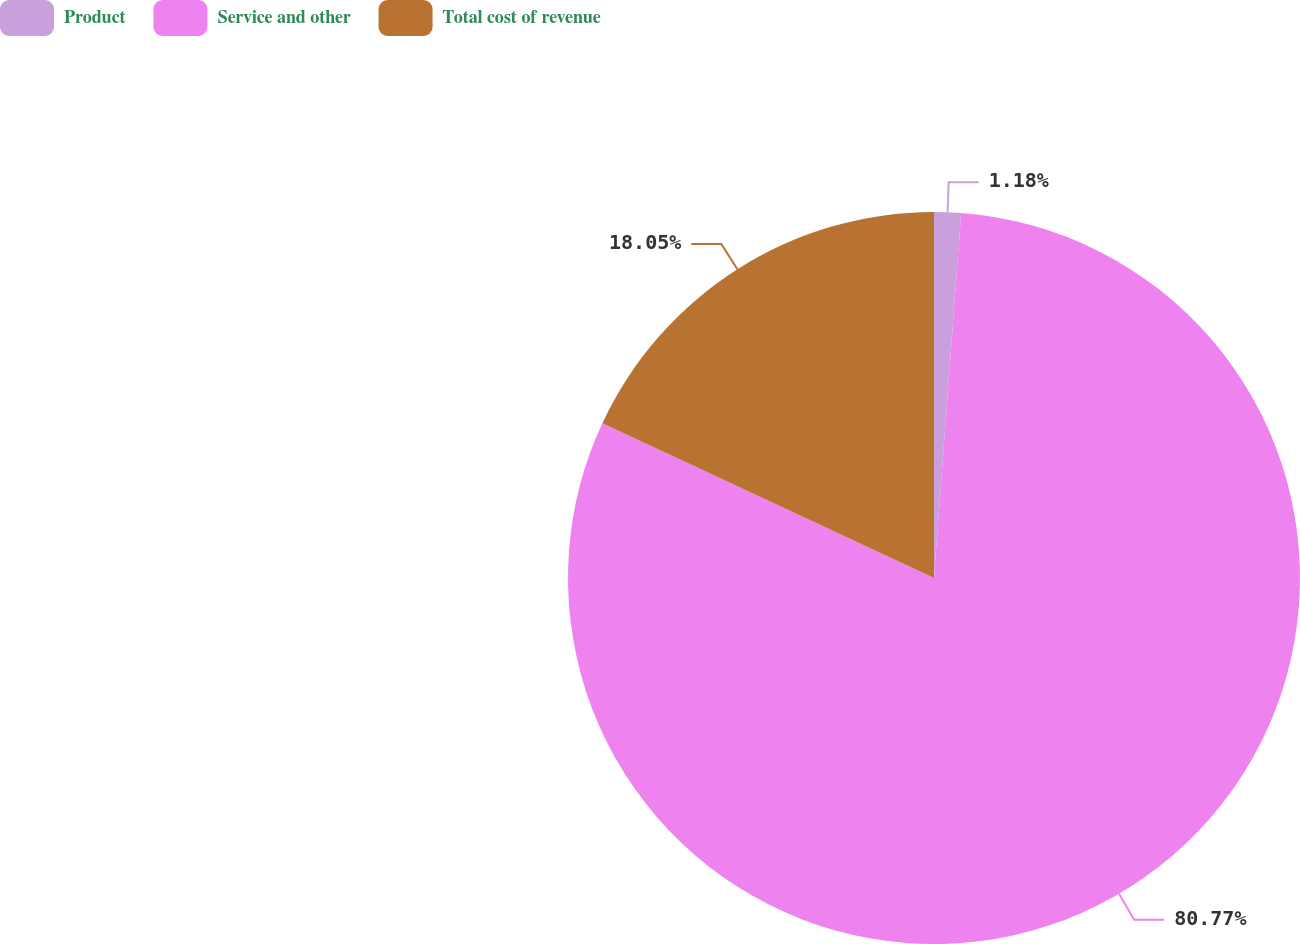Convert chart to OTSL. <chart><loc_0><loc_0><loc_500><loc_500><pie_chart><fcel>Product<fcel>Service and other<fcel>Total cost of revenue<nl><fcel>1.18%<fcel>80.77%<fcel>18.05%<nl></chart> 